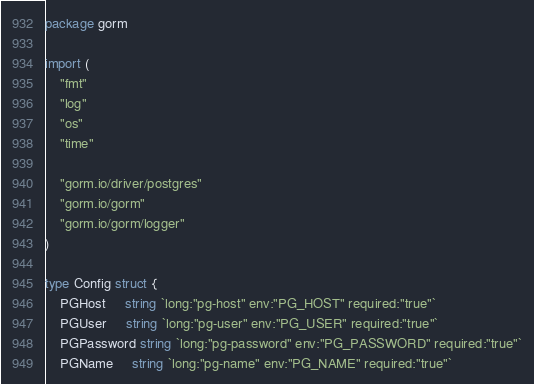Convert code to text. <code><loc_0><loc_0><loc_500><loc_500><_Go_>package gorm

import (
	"fmt"
	"log"
	"os"
	"time"

	"gorm.io/driver/postgres"
	"gorm.io/gorm"
	"gorm.io/gorm/logger"
)

type Config struct {
	PGHost     string `long:"pg-host" env:"PG_HOST" required:"true"`
	PGUser     string `long:"pg-user" env:"PG_USER" required:"true"`
	PGPassword string `long:"pg-password" env:"PG_PASSWORD" required:"true"`
	PGName     string `long:"pg-name" env:"PG_NAME" required:"true"`</code> 